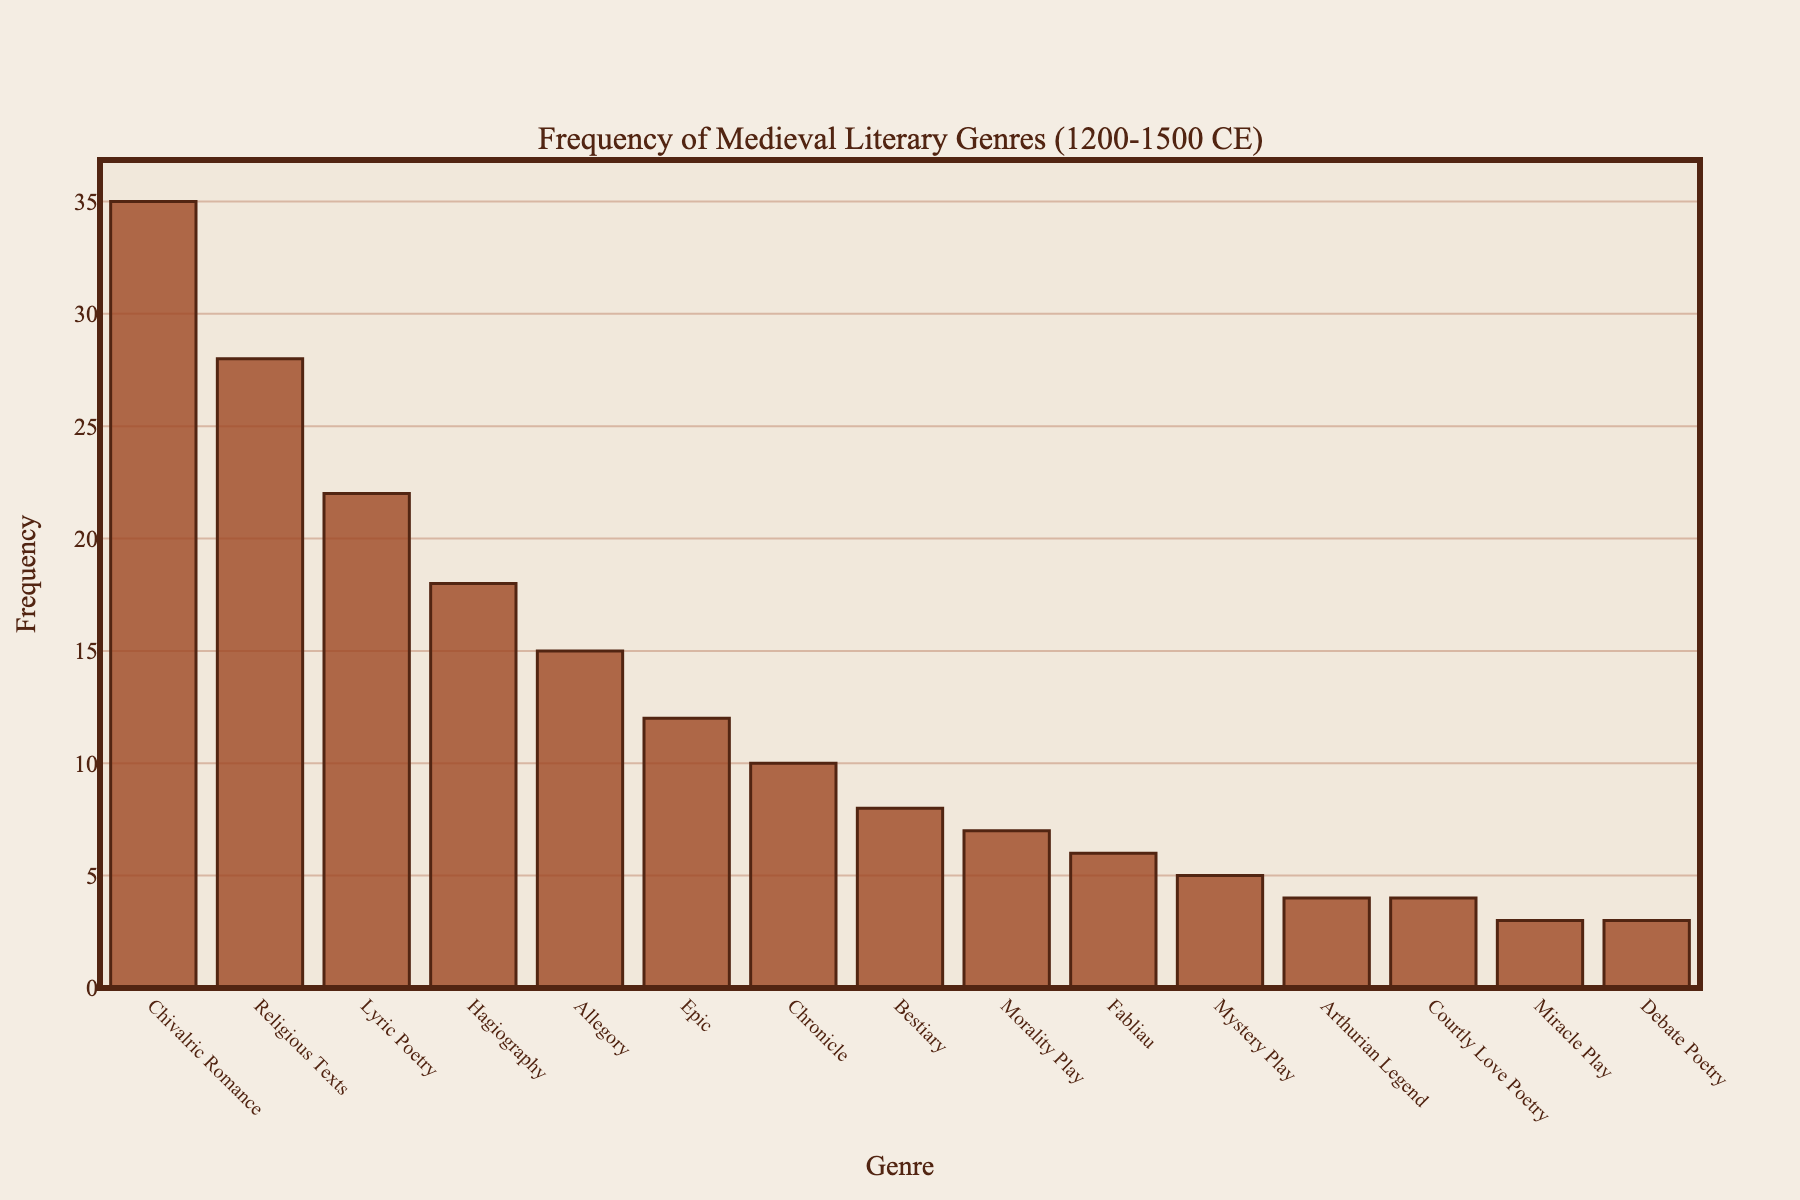Which genre has the highest frequency in the chart? The genre with the tallest bar represents the highest frequency. This is "Chivalric Romance" with a frequency of 35.
Answer: Chivalric Romance Which genre appears least frequently in the manuscripts? The genre with the shortest bar represents the lowest frequency. This is "Debate Poetry" and "Miracle Play," both having a frequency of 3.
Answer: Debate Poetry, Miracle Play How many more manuscripts contain Chivalric Romance than Mystery Play? Chivalric Romance has a frequency of 35, and Mystery Play has a frequency of 5. The difference is 35 - 5 = 30.
Answer: 30 What is the total frequency of genres under 10? The genres under 10 are Bestiary (8), Morality Play (7), Fabliau (6), Mystery Play (5), Arthurian Legend (4), Courtly Love Poetry (4), Miracle Play (3), and Debate Poetry (3). Their sum is 8 + 7 + 6 + 5 + 4 + 4 + 3 + 3 = 40.
Answer: 40 Compare the frequency of Lyric Poetry to that of Epic. Which is higher and by how much? Lyric Poetry has a frequency of 22, and Epic has a frequency of 12. Lyric Poetry is higher by 22 - 12 = 10.
Answer: Lyric Poetry, 10 What is the average frequency of all genres? The dataset has 15 genres. Summing their frequencies gives 35 + 28 + 22 + 18 + 15 + 12 + 10 + 8 + 7 + 6 + 5 + 4 + 4 + 3 + 3 = 180. The average is 180 / 15 = 12.
Answer: 12 Identify the genres that have a frequency between 10 and 20. Genres with frequencies between 10 and 20 are Hagiography (18), Allegory (15), and Epic (12).
Answer: Hagiography, Allegory, Epic What is the combined frequency of the top three genres? The top three genres are Chivalric Romance (35), Religious Texts (28), and Lyric Poetry (22). Their combined frequency is 35 + 28 + 22 = 85.
Answer: 85 